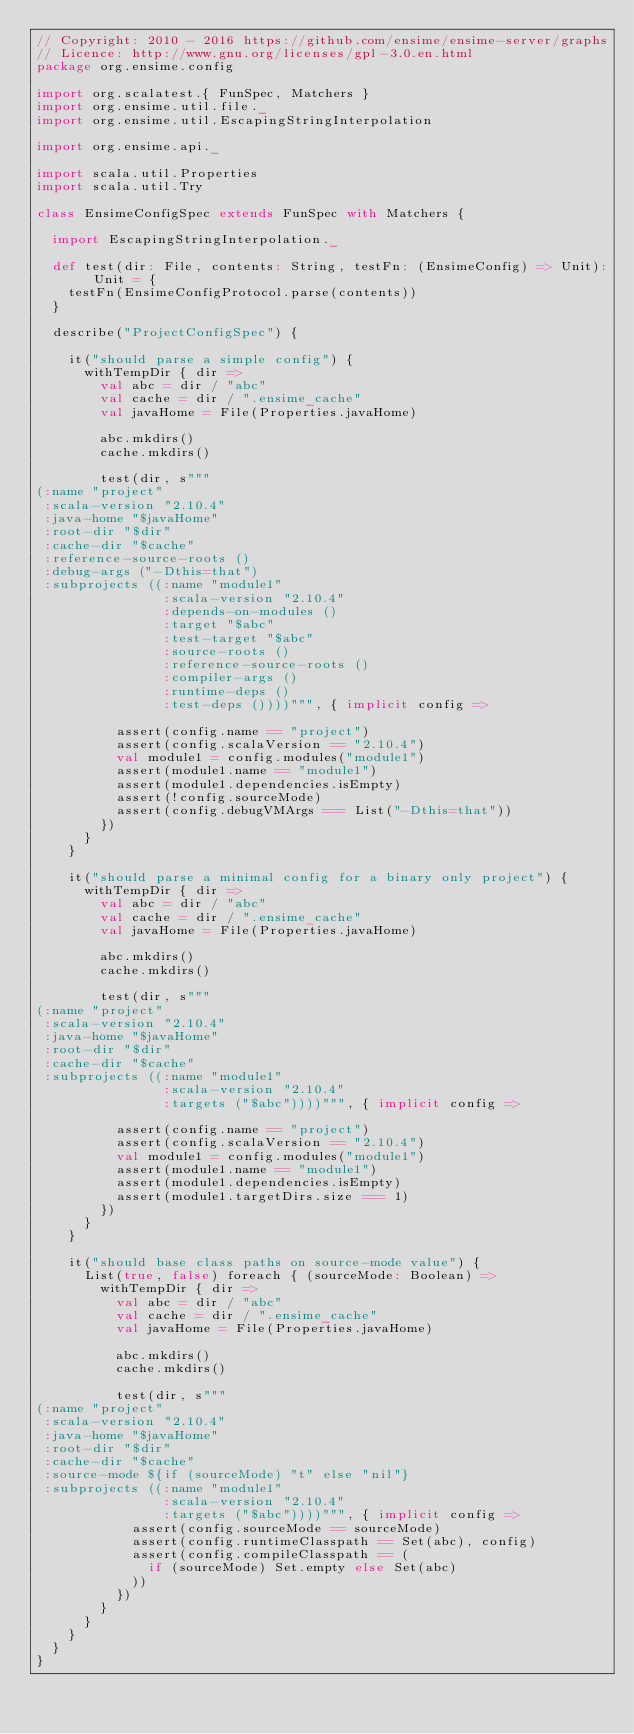Convert code to text. <code><loc_0><loc_0><loc_500><loc_500><_Scala_>// Copyright: 2010 - 2016 https://github.com/ensime/ensime-server/graphs
// Licence: http://www.gnu.org/licenses/gpl-3.0.en.html
package org.ensime.config

import org.scalatest.{ FunSpec, Matchers }
import org.ensime.util.file._
import org.ensime.util.EscapingStringInterpolation

import org.ensime.api._

import scala.util.Properties
import scala.util.Try

class EnsimeConfigSpec extends FunSpec with Matchers {

  import EscapingStringInterpolation._

  def test(dir: File, contents: String, testFn: (EnsimeConfig) => Unit): Unit = {
    testFn(EnsimeConfigProtocol.parse(contents))
  }

  describe("ProjectConfigSpec") {

    it("should parse a simple config") {
      withTempDir { dir =>
        val abc = dir / "abc"
        val cache = dir / ".ensime_cache"
        val javaHome = File(Properties.javaHome)

        abc.mkdirs()
        cache.mkdirs()

        test(dir, s"""
(:name "project"
 :scala-version "2.10.4"
 :java-home "$javaHome"
 :root-dir "$dir"
 :cache-dir "$cache"
 :reference-source-roots ()
 :debug-args ("-Dthis=that")
 :subprojects ((:name "module1"
                :scala-version "2.10.4"
                :depends-on-modules ()
                :target "$abc"
                :test-target "$abc"
                :source-roots ()
                :reference-source-roots ()
                :compiler-args ()
                :runtime-deps ()
                :test-deps ())))""", { implicit config =>

          assert(config.name == "project")
          assert(config.scalaVersion == "2.10.4")
          val module1 = config.modules("module1")
          assert(module1.name == "module1")
          assert(module1.dependencies.isEmpty)
          assert(!config.sourceMode)
          assert(config.debugVMArgs === List("-Dthis=that"))
        })
      }
    }

    it("should parse a minimal config for a binary only project") {
      withTempDir { dir =>
        val abc = dir / "abc"
        val cache = dir / ".ensime_cache"
        val javaHome = File(Properties.javaHome)

        abc.mkdirs()
        cache.mkdirs()

        test(dir, s"""
(:name "project"
 :scala-version "2.10.4"
 :java-home "$javaHome"
 :root-dir "$dir"
 :cache-dir "$cache"
 :subprojects ((:name "module1"
                :scala-version "2.10.4"
                :targets ("$abc"))))""", { implicit config =>

          assert(config.name == "project")
          assert(config.scalaVersion == "2.10.4")
          val module1 = config.modules("module1")
          assert(module1.name == "module1")
          assert(module1.dependencies.isEmpty)
          assert(module1.targetDirs.size === 1)
        })
      }
    }

    it("should base class paths on source-mode value") {
      List(true, false) foreach { (sourceMode: Boolean) =>
        withTempDir { dir =>
          val abc = dir / "abc"
          val cache = dir / ".ensime_cache"
          val javaHome = File(Properties.javaHome)

          abc.mkdirs()
          cache.mkdirs()

          test(dir, s"""
(:name "project"
 :scala-version "2.10.4"
 :java-home "$javaHome"
 :root-dir "$dir"
 :cache-dir "$cache"
 :source-mode ${if (sourceMode) "t" else "nil"}
 :subprojects ((:name "module1"
                :scala-version "2.10.4"
                :targets ("$abc"))))""", { implicit config =>
            assert(config.sourceMode == sourceMode)
            assert(config.runtimeClasspath == Set(abc), config)
            assert(config.compileClasspath == (
              if (sourceMode) Set.empty else Set(abc)
            ))
          })
        }
      }
    }
  }
}
</code> 